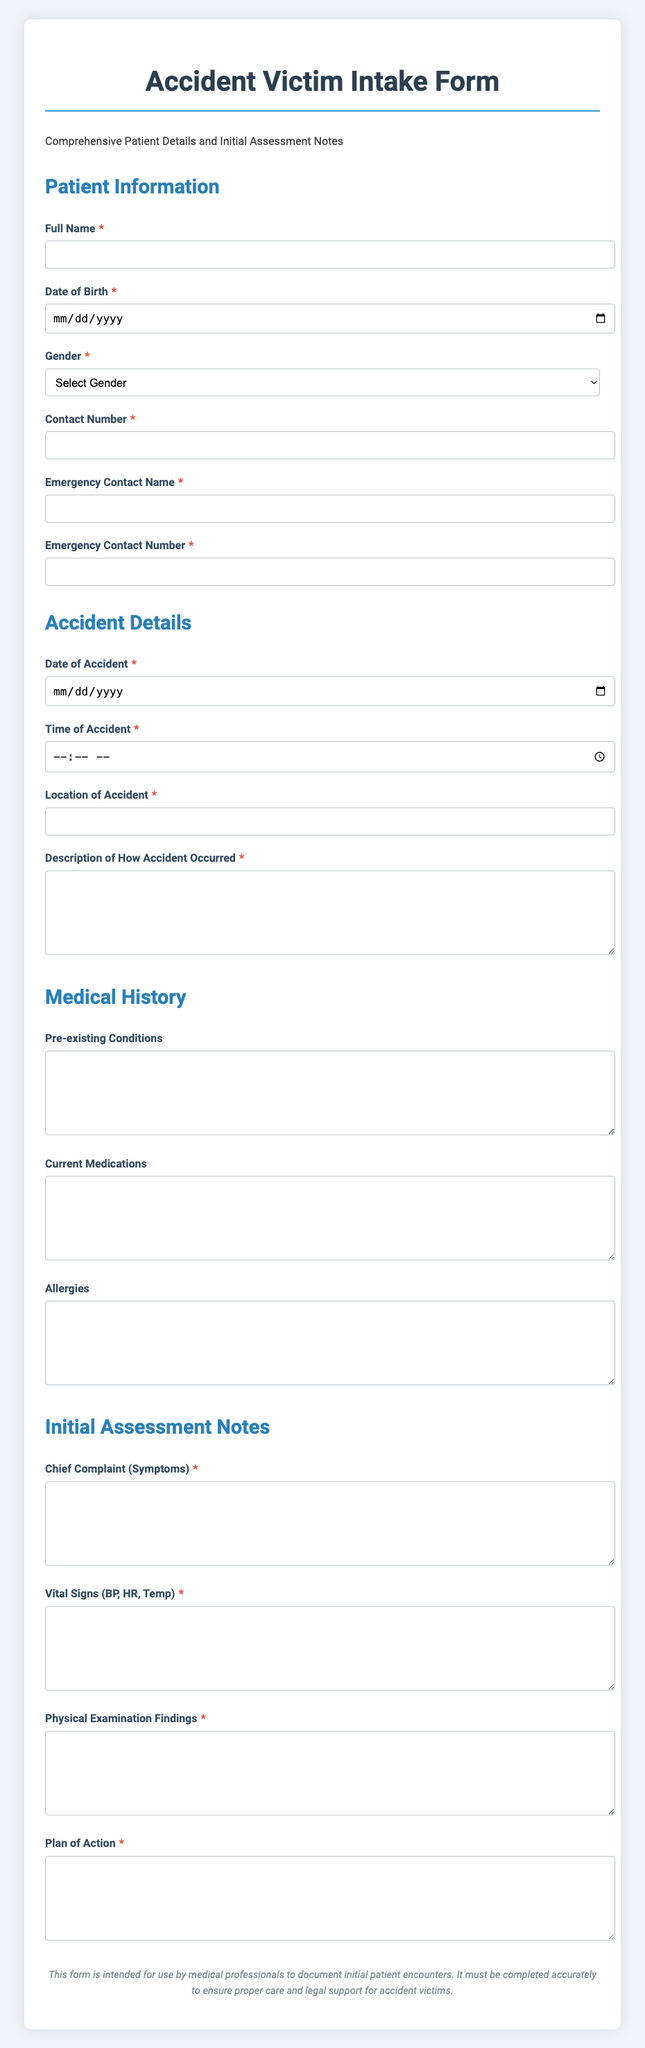What is the title of the document? The title is prominently displayed at the top of the document, indicating its purpose.
Answer: Accident Victim Intake Form What is the required contact number label? The document specifies a label for this field to guide data entry.
Answer: Contact Number What date format is used for the date of birth input? The input field indicates the expected format for the date through its type.
Answer: Date How many sections are present in the form? Each section is categorized under relevant headings for organized data entry.
Answer: Four What is the required action for the pre-existing conditions field? This field requires the patient to provide specific medical history information.
Answer: Fill in details What type of information is requested for chief complaint? The field specifically asks for a summary of symptoms from the patient.
Answer: Symptoms What is the intended use of the form stated in the footer? The footer clarifies the primary purpose of completing this form accurately.
Answer: Document initial patient encounters What is the color of the header text? The header's color enhances visibility and clarity at the top of the document.
Answer: Dark blue What should be included in the plan of action section? This section allows healthcare professionals to outline future steps for patient care.
Answer: Future patient care steps 